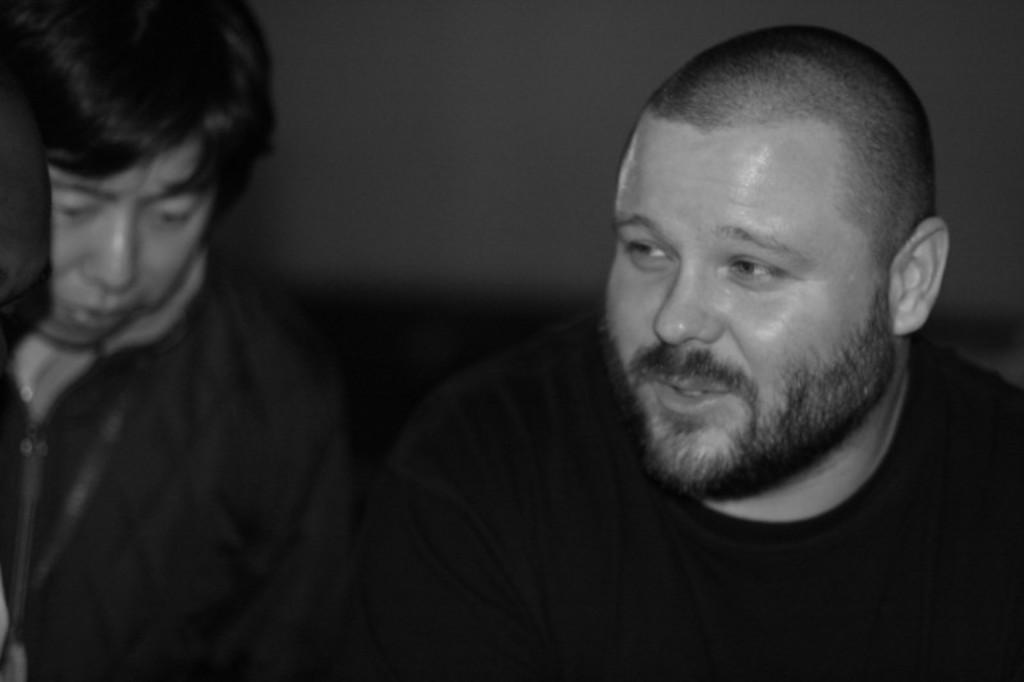What is the color scheme of the image? The image is black and white. How many people are present in the image? There are two people in the image. What can be seen in the background of the image? There is a wall visible in the image. How do the people in the image maintain their balance while walking on the wall? There is no indication in the image that the people are walking on the wall, and therefore no such balancing act can be observed. 